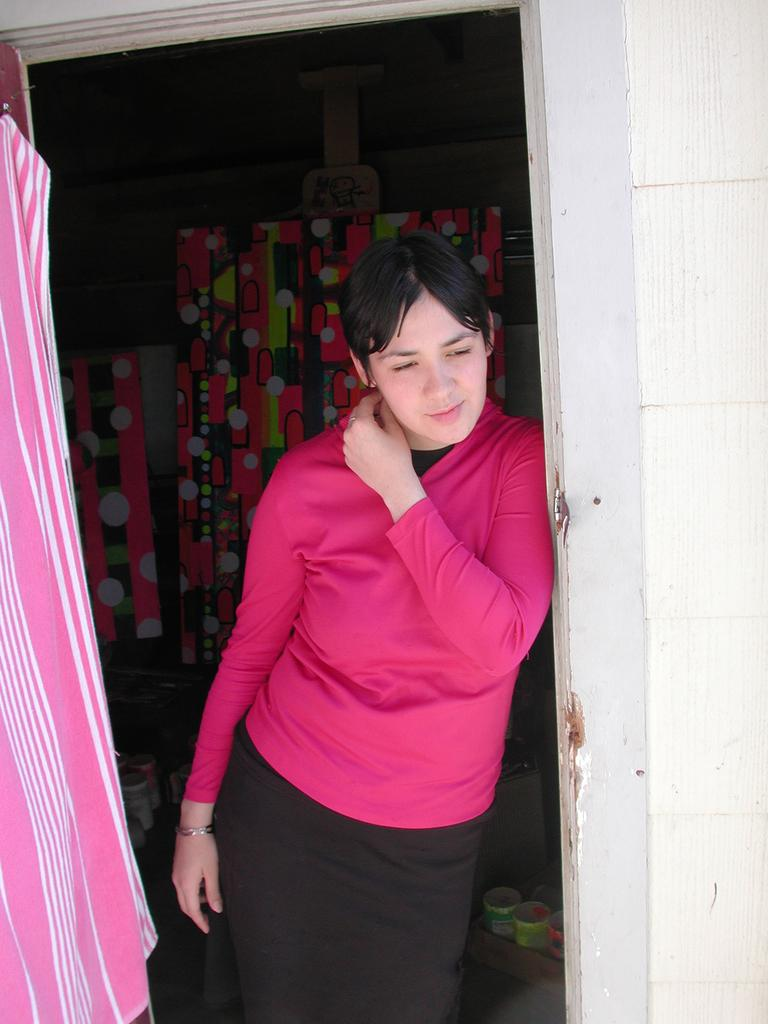Who is present in the image? There is a woman in the image. What is the woman wearing? The woman is wearing a pink T-shirt. What objects can be seen behind the woman? There are bottles visible behind the woman. What type of camera is the woman using to take pictures in space? There is no camera or space depicted in the image; it features a woman wearing a pink T-shirt with bottles visible behind her. Is the woman driving a car in the image? There is no car or driving depicted in the image; it features a woman wearing a pink T-shirt with bottles visible behind her. 